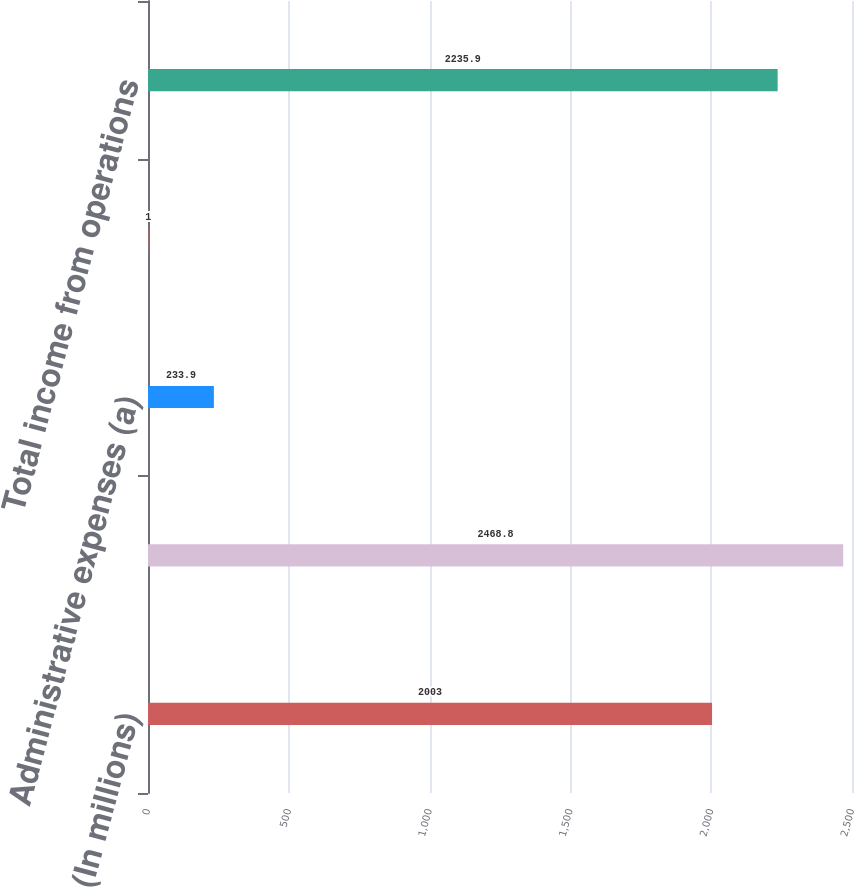Convert chart. <chart><loc_0><loc_0><loc_500><loc_500><bar_chart><fcel>(In millions)<fcel>Segment income<fcel>Administrative expenses (a)<fcel>Gain (loss) on ownership<fcel>Total income from operations<nl><fcel>2003<fcel>2468.8<fcel>233.9<fcel>1<fcel>2235.9<nl></chart> 